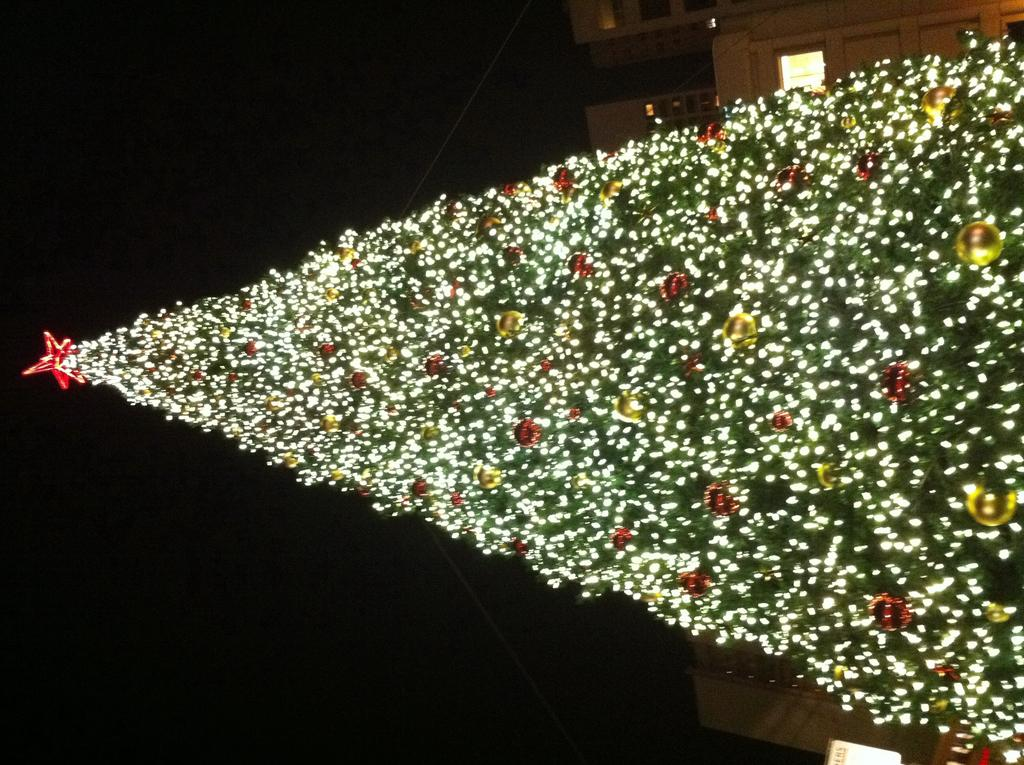What type of tree is in the image? There is a Christmas tree in the image. How is the Christmas tree decorated? The Christmas tree is decorated with lights and balls. What is on top of the Christmas tree? There is a star on top of the Christmas tree. What type of feather can be seen on the Christmas tree in the image? There are no feathers present on the Christmas tree in the image. What song is being played in the background of the image? There is no information about any music or songs in the image. 